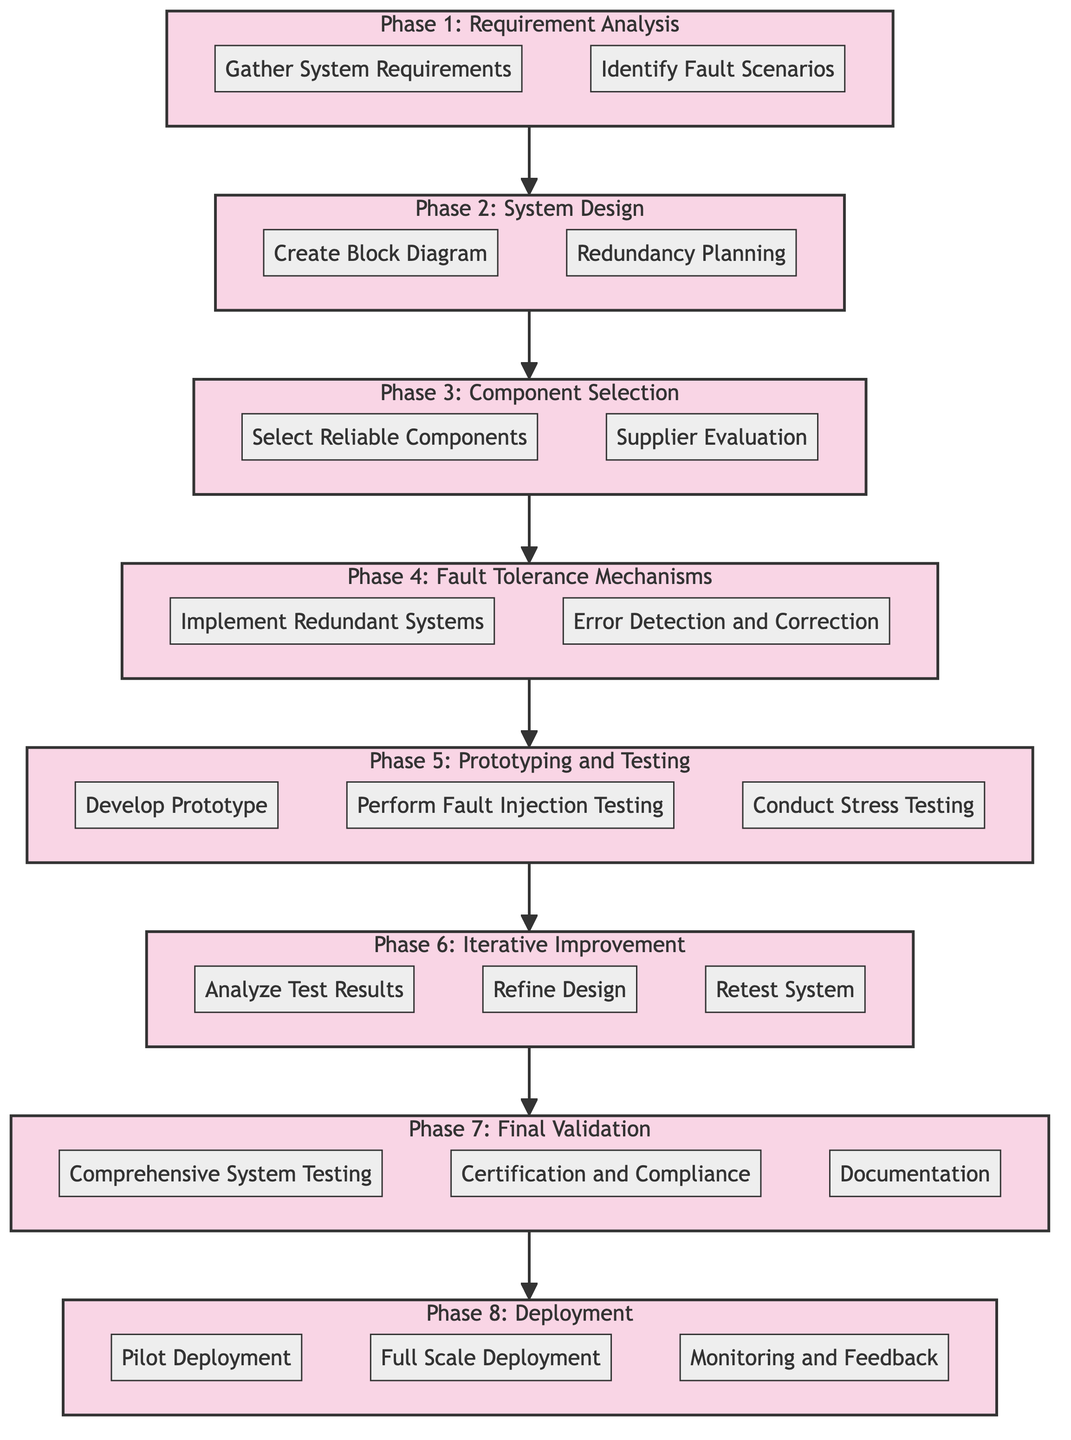What are the two steps listed in Phase 1? In Phase 1: Requirement Analysis, the steps are Gather System Requirements and Identify Fault Scenarios. Each step can be found clearly labeled under Phase 1.
Answer: Gather System Requirements, Identify Fault Scenarios How many phases are there in the process? The diagram includes eight phases, with each phase distinctly labeled and organized sequentially from Phase 1 to Phase 8.
Answer: Eight What comes immediately after 'Supplier Evaluation'? Following 'Supplier Evaluation' in Phase 3: Component Selection, the next step is 'Implement Redundant Systems' in Phase 4: Fault Tolerance Mechanisms. This shows the progression from component selection to implementing fault tolerance measures.
Answer: Implement Redundant Systems What is the last step before deployment? The last step before deployment is 'Final Validation', specifically the final step labeled as 'Documentation.' This is a part of the various validation tasks that must occur before moving to deployment.
Answer: Documentation How many steps are in Phase 5? Phase 5: Prototyping and Testing consists of three steps: Develop Prototype, Perform Fault Injection Testing, and Conduct Stress Testing. Each step is listed as part of this specific phase.
Answer: Three What phase includes 'Redundancy Planning'? The step 'Redundancy Planning' is included in Phase 2: System Design, illustrating the need for creating a design that incorporates redundancy for reliability.
Answer: Phase 2: System Design What mechanism is associated with error handling? The mechanism associated with error handling is 'Error Detection and Correction', which is part of Phase 4: Fault Tolerance Mechanisms. This step emphasizes the integration of strategies to manage errors effectively.
Answer: Error Detection and Correction What is the purpose of 'Pilot Deployment'? 'Pilot Deployment' aims to conduct an initial deployment in a controlled environment to assess the system's functioning before full-scale implementation. This is critical for testing the system's performance in a real-world setting.
Answer: Conduct initial deployment in a controlled environment 